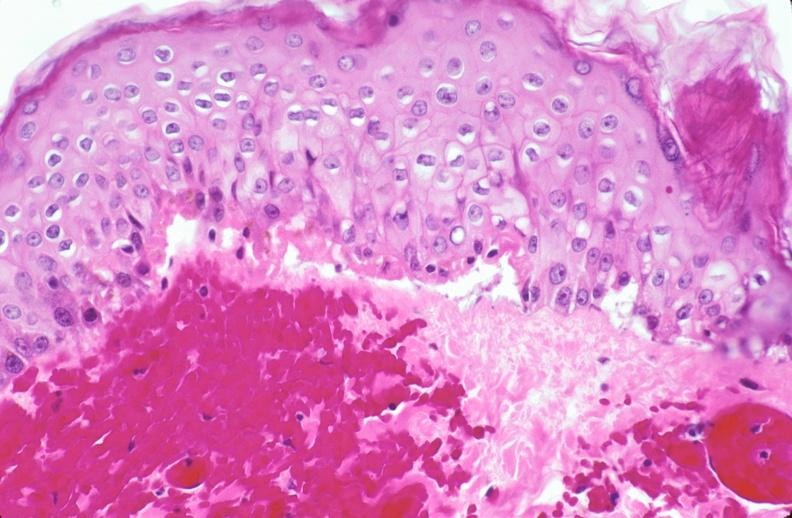does this image show skin, epidermolysis bullosa?
Answer the question using a single word or phrase. Yes 